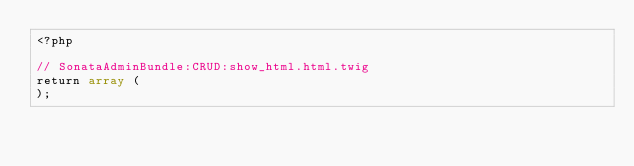Convert code to text. <code><loc_0><loc_0><loc_500><loc_500><_PHP_><?php

// SonataAdminBundle:CRUD:show_html.html.twig
return array (
);
</code> 